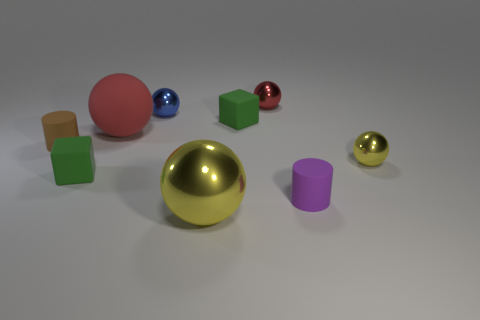Subtract all green blocks. How many were subtracted if there are1green blocks left? 1 Subtract all cyan cubes. How many red balls are left? 2 Subtract all big rubber balls. How many balls are left? 4 Subtract 3 spheres. How many spheres are left? 2 Subtract all red balls. How many balls are left? 3 Add 1 big yellow spheres. How many objects exist? 10 Subtract all cyan spheres. Subtract all red cylinders. How many spheres are left? 5 Subtract all cylinders. How many objects are left? 7 Subtract all small brown matte spheres. Subtract all tiny red balls. How many objects are left? 8 Add 2 large red matte objects. How many large red matte objects are left? 3 